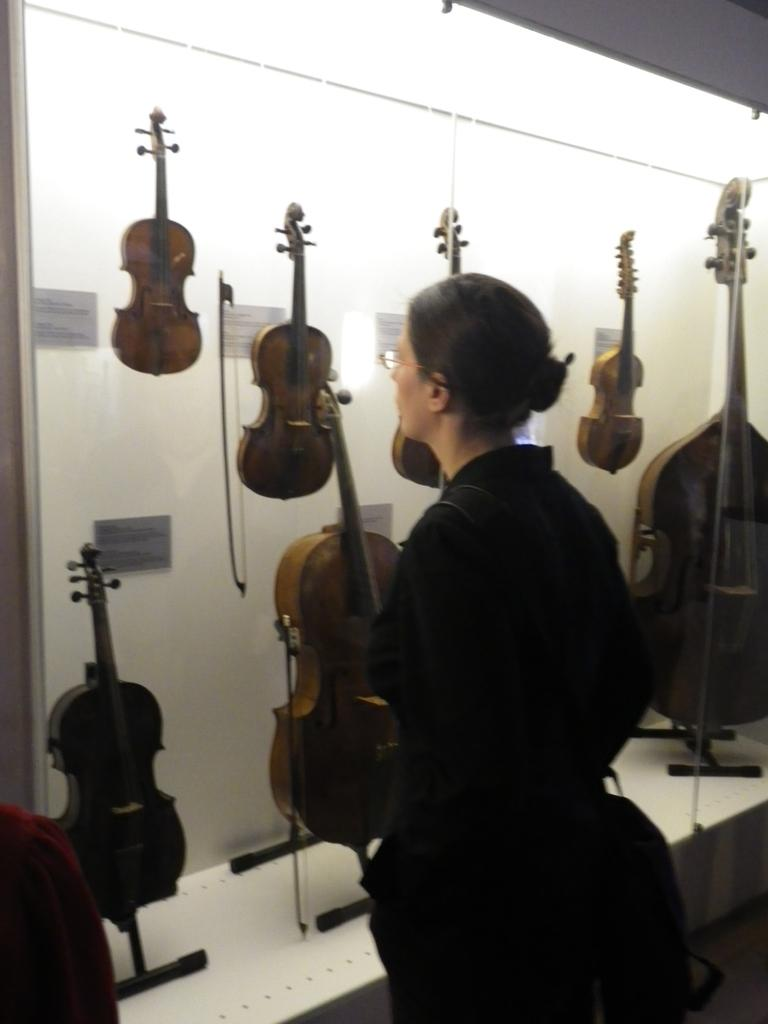Who is the main subject in the image? There is a woman in the image. What is the woman looking at? The woman is looking at violins. Where are the violins located in relation to the woman? The violins are in front of the woman. What time is the woman's journey starting in the image? There is no information about a journey or time in the image; it only shows a woman looking at violins. 